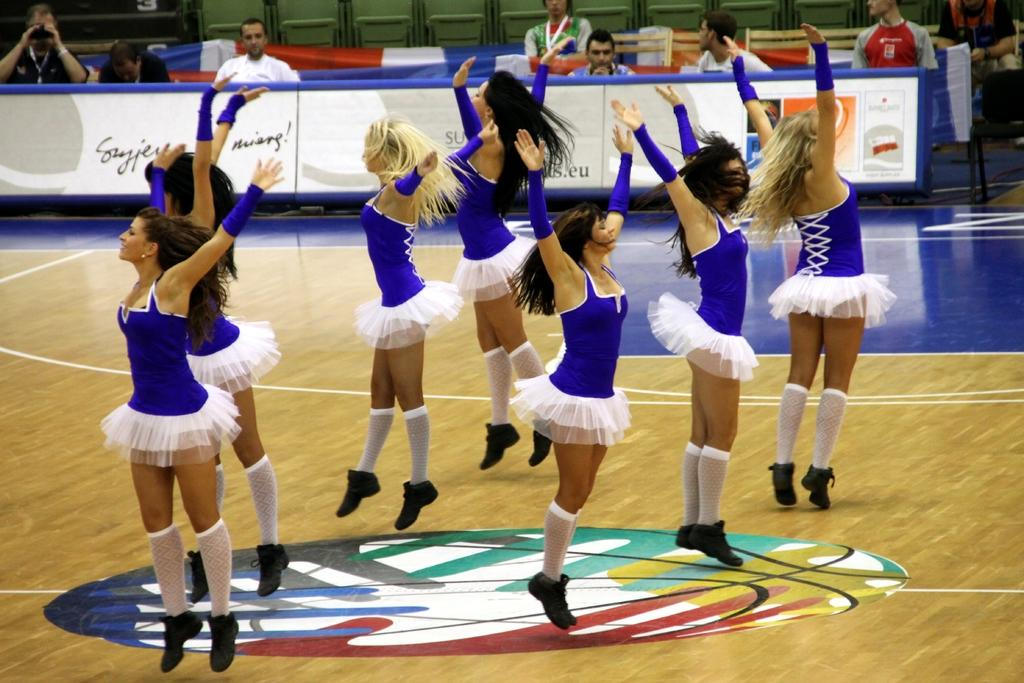What are the people in the image doing? There are people dancing in the image. What are the people in the background of the image doing? The people in the background are sitting. What can be seen flying or waving in the image? There is a flag visible in the image. What type of furniture is present in the image? There are boards and chairs in the image. What type of soup is being served in the image? There is no soup present in the image. What type of stitch is being used to create the flag in the image? The image does not show the process of creating the flag, so it is not possible to determine the type of stitch used. 